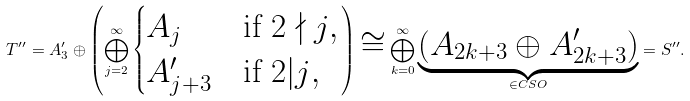<formula> <loc_0><loc_0><loc_500><loc_500>T ^ { \prime \prime } = A ^ { \prime } _ { 3 } \oplus \left ( \bigoplus _ { j = 2 } ^ { \infty } \begin{cases} A _ { j } & \text {if $2 \nmid j$} , \\ A ^ { \prime } _ { j + 3 } & \text {if $2 | j$} , \end{cases} \right ) \cong \bigoplus _ { k = 0 } ^ { \infty } \underbrace { ( A _ { 2 k + 3 } \oplus A ^ { \prime } _ { 2 k + 3 } ) } _ { \in C S O } = S ^ { \prime \prime } .</formula> 